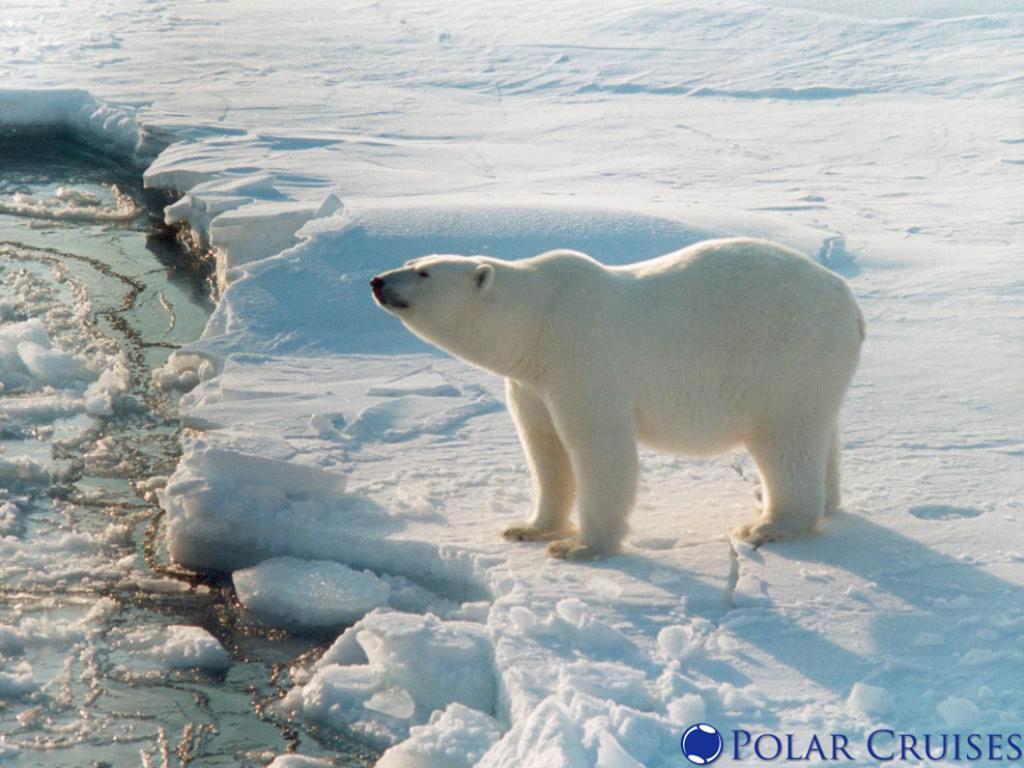In one or two sentences, can you explain what this image depicts? In this picture I can see a polar bear on the snow, there is water, and there is a watermark on the image. 